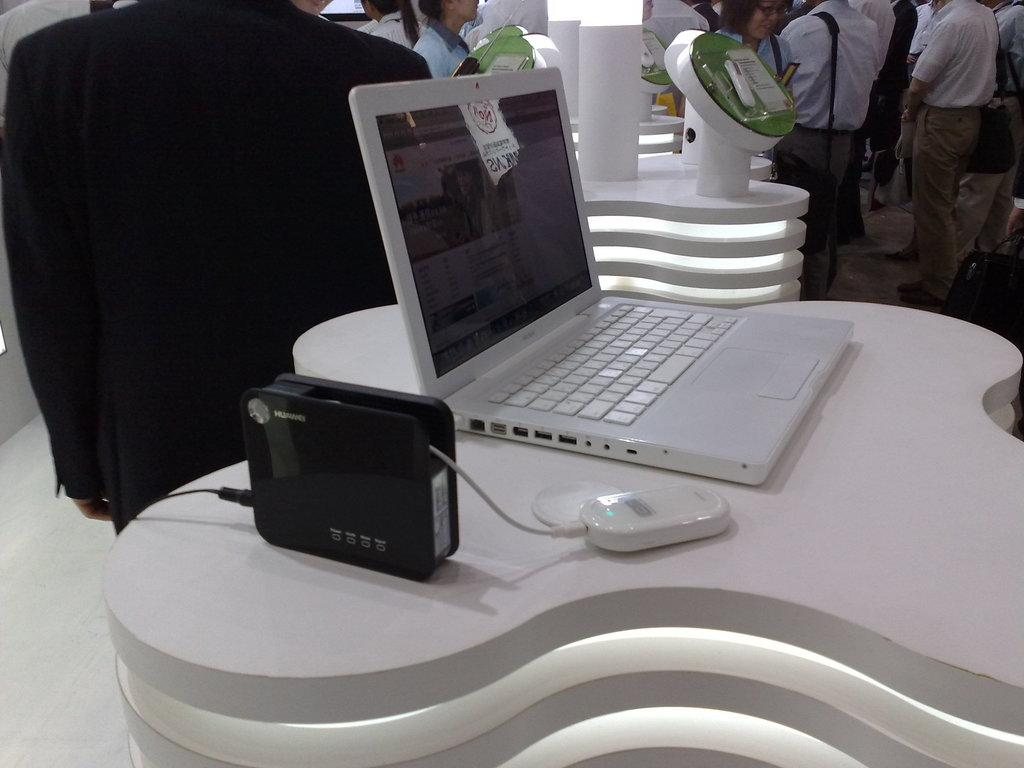What electronic device is visible in the image? There is a laptop in the image. What is the laptop placed on or near in the image? There are devices on a platform in the image. What can be seen in the background of the image? There is a group of people and objects visible in the background of the image. What type of reward is being given to the person in the image? There is no reward being given in the image; it only shows a laptop, devices on a platform, and a group of people in the background. 